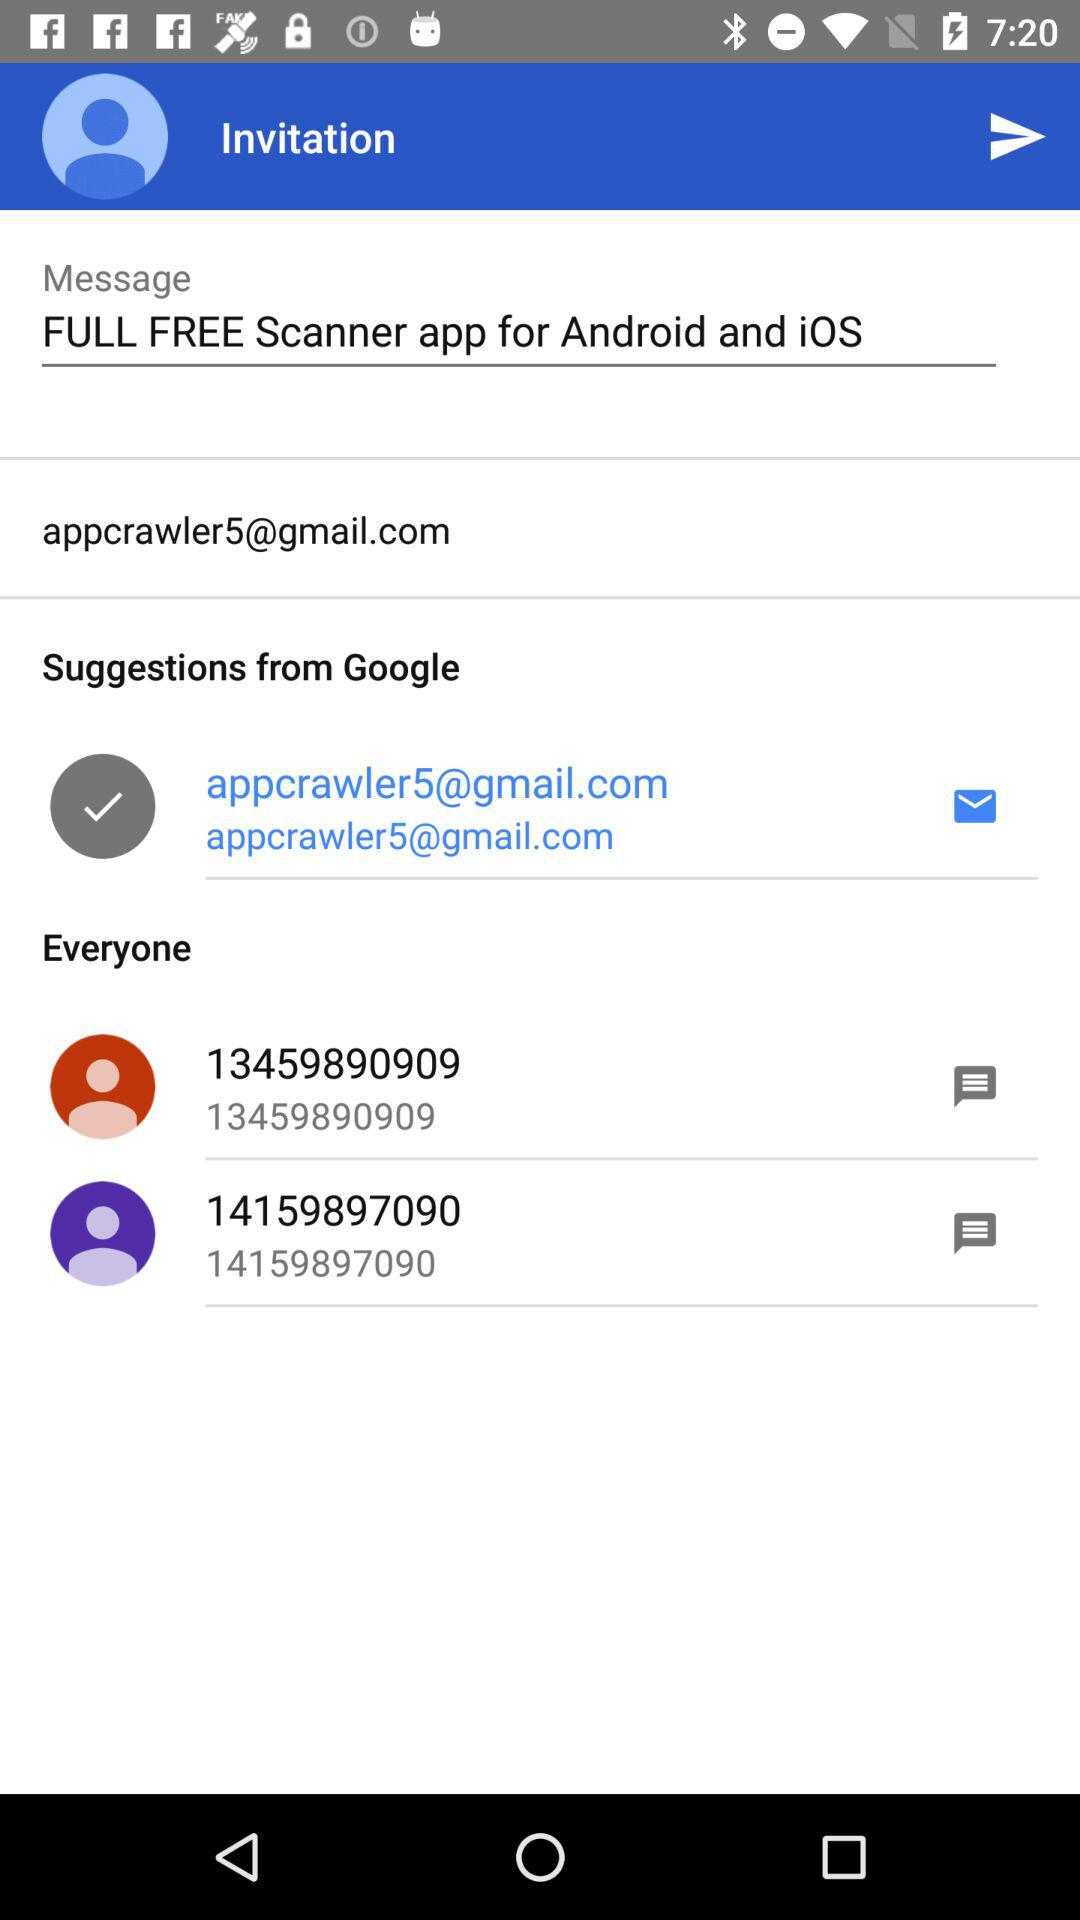What is the contact number? The contact numbers are 13459890909 and 14159897090. 